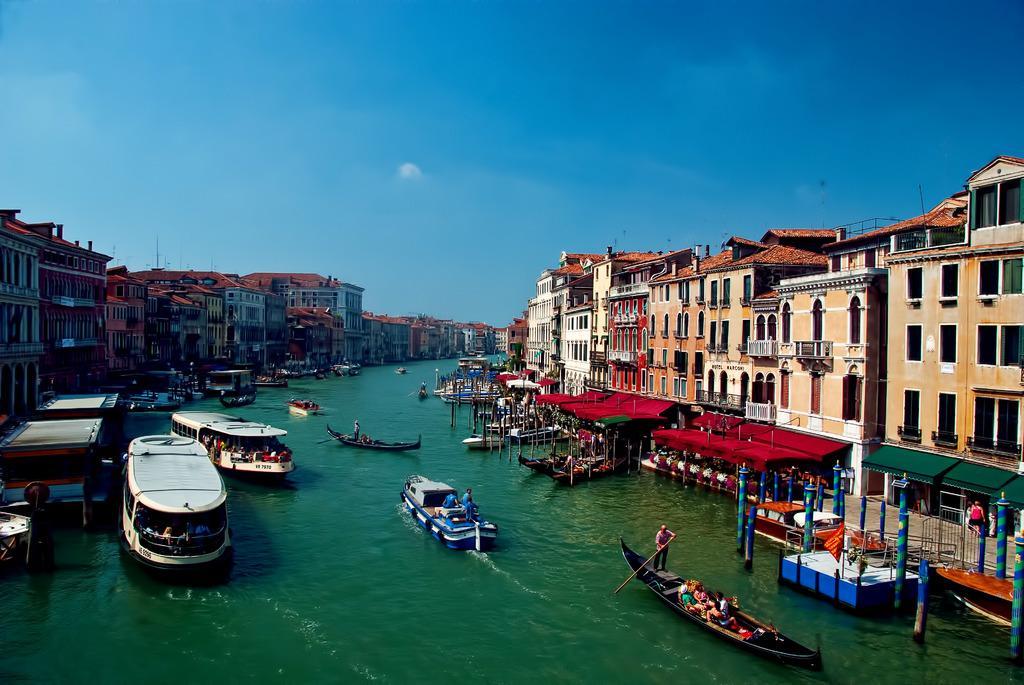Describe this image in one or two sentences. In this image we can see the canal. There are so many boats in the canal many people are there in that boats. One man is sailing the boat. So many different types of buildings around the canal. At the top sky, is there. In front of one building near canal one flag is there. One woman is walking in front of one building. So many people are sitting in another building. 